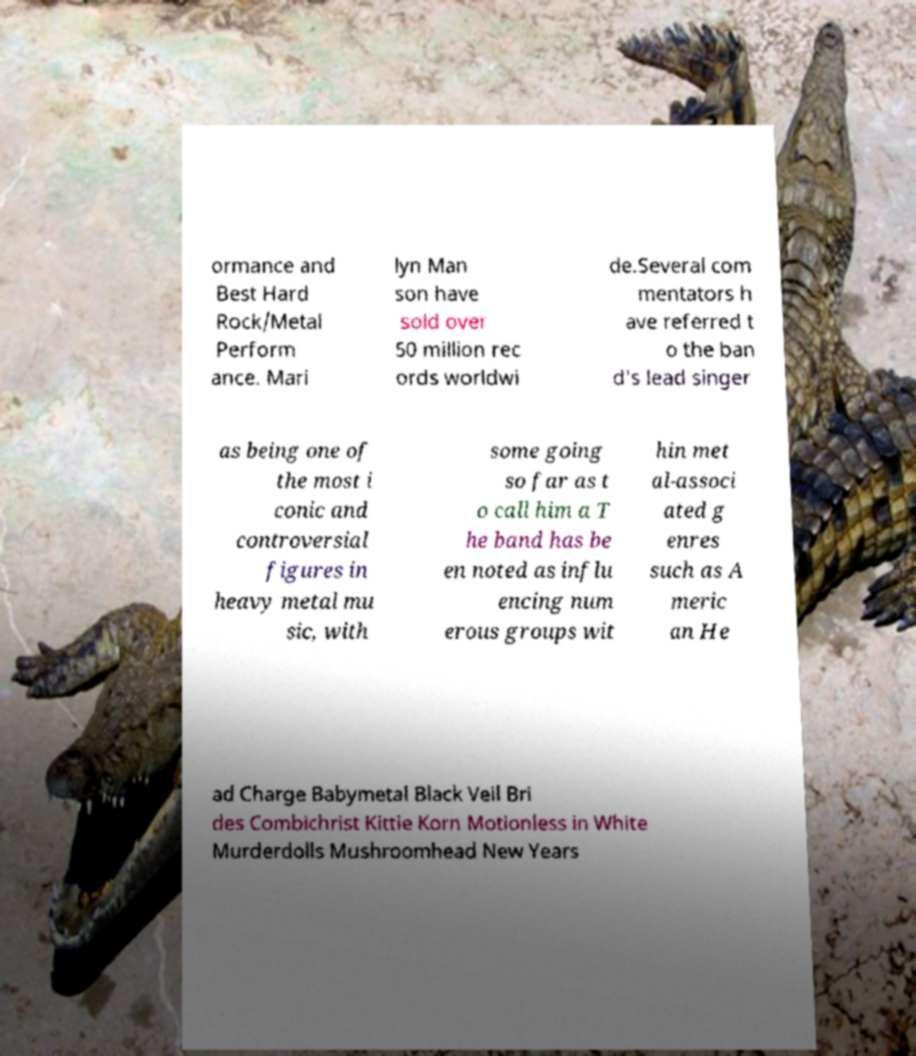Please identify and transcribe the text found in this image. ormance and Best Hard Rock/Metal Perform ance. Mari lyn Man son have sold over 50 million rec ords worldwi de.Several com mentators h ave referred t o the ban d's lead singer as being one of the most i conic and controversial figures in heavy metal mu sic, with some going so far as t o call him a T he band has be en noted as influ encing num erous groups wit hin met al-associ ated g enres such as A meric an He ad Charge Babymetal Black Veil Bri des Combichrist Kittie Korn Motionless in White Murderdolls Mushroomhead New Years 